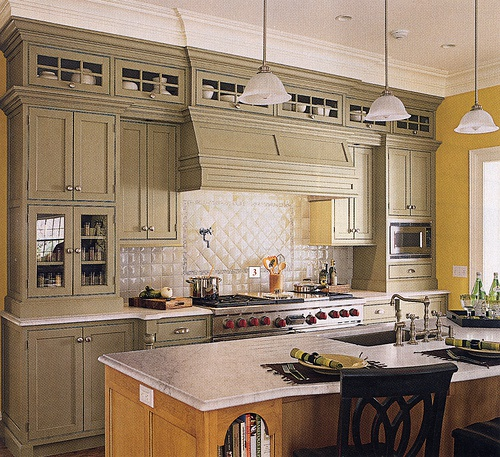Describe the objects in this image and their specific colors. I can see chair in tan, black, maroon, and gray tones, oven in tan, lightgray, black, gray, and darkgray tones, microwave in tan, black, gray, and lightgray tones, oven in tan, gray, black, and lightgray tones, and sink in tan, black, darkgray, and gray tones in this image. 